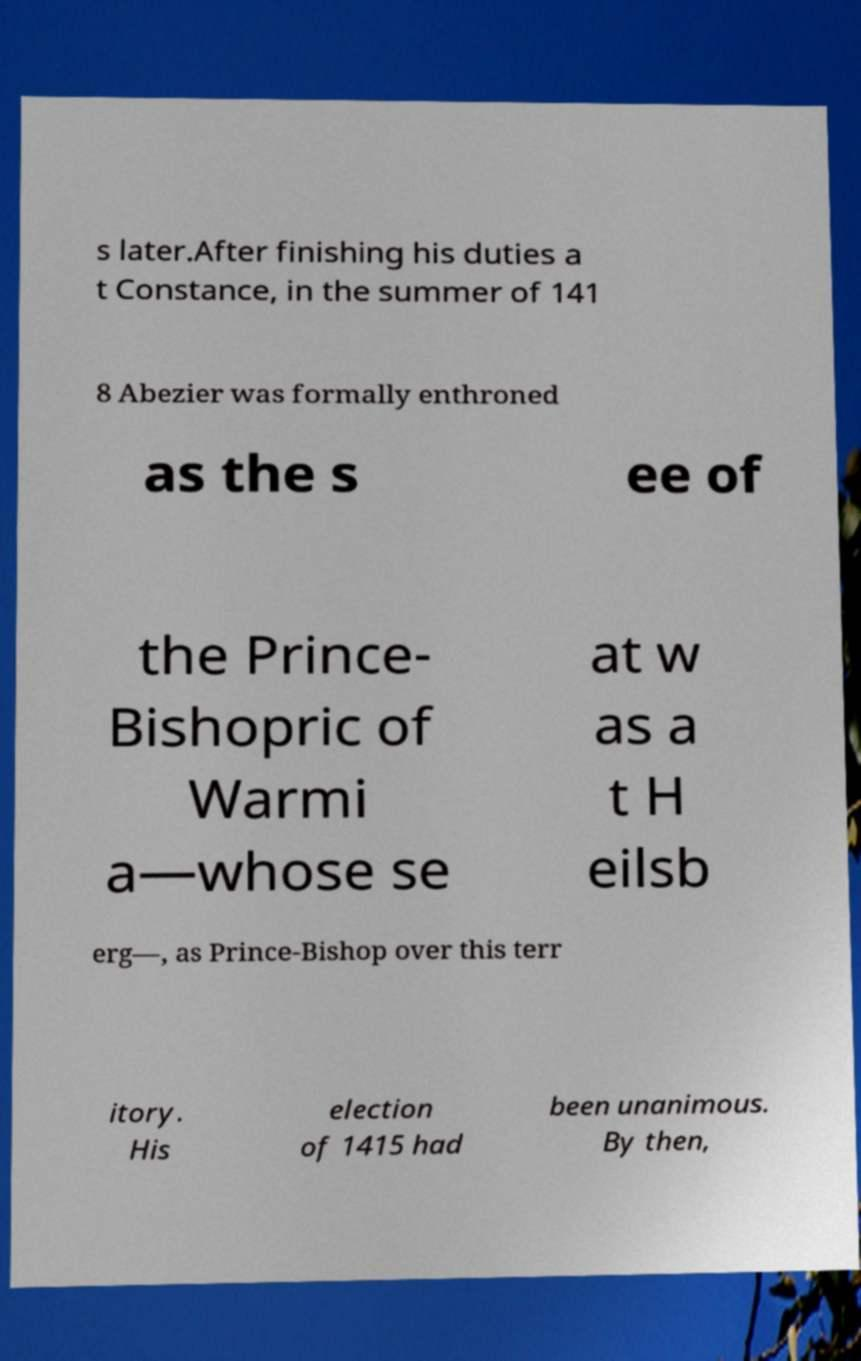Could you assist in decoding the text presented in this image and type it out clearly? s later.After finishing his duties a t Constance, in the summer of 141 8 Abezier was formally enthroned as the s ee of the Prince- Bishopric of Warmi a—whose se at w as a t H eilsb erg—, as Prince-Bishop over this terr itory. His election of 1415 had been unanimous. By then, 